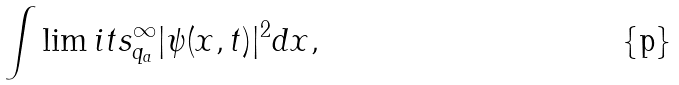<formula> <loc_0><loc_0><loc_500><loc_500>\int \lim i t s _ { q _ { a } } ^ { \infty } | \psi ( x , t ) | ^ { 2 } d x ,</formula> 